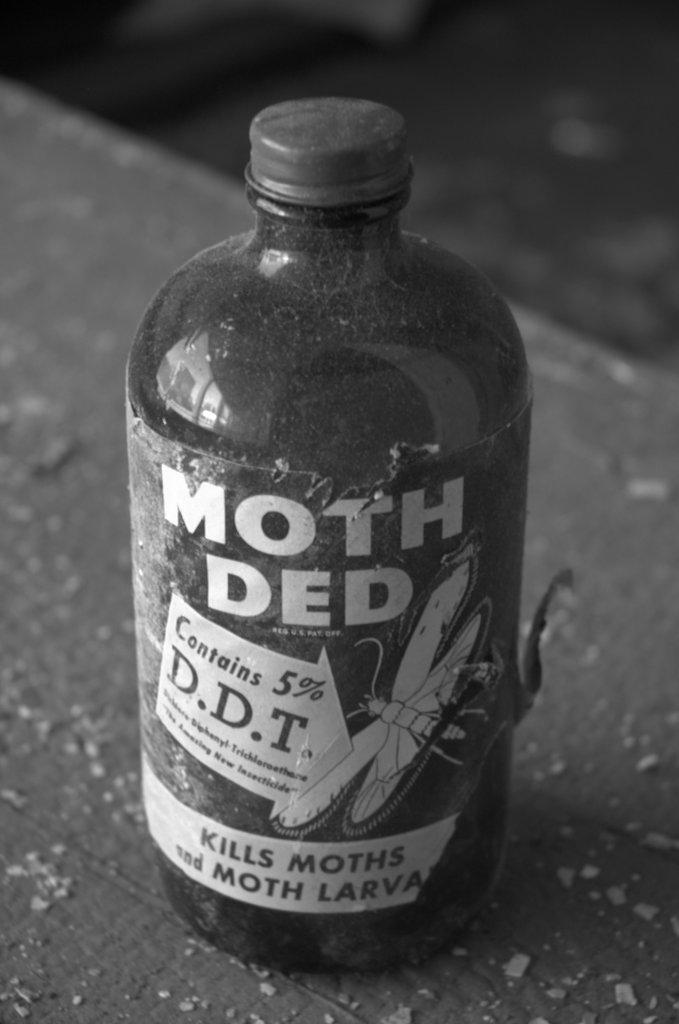<image>
Describe the image concisely. A bottle of Moth Ded insect killer that "kills moths and moth larvae" 